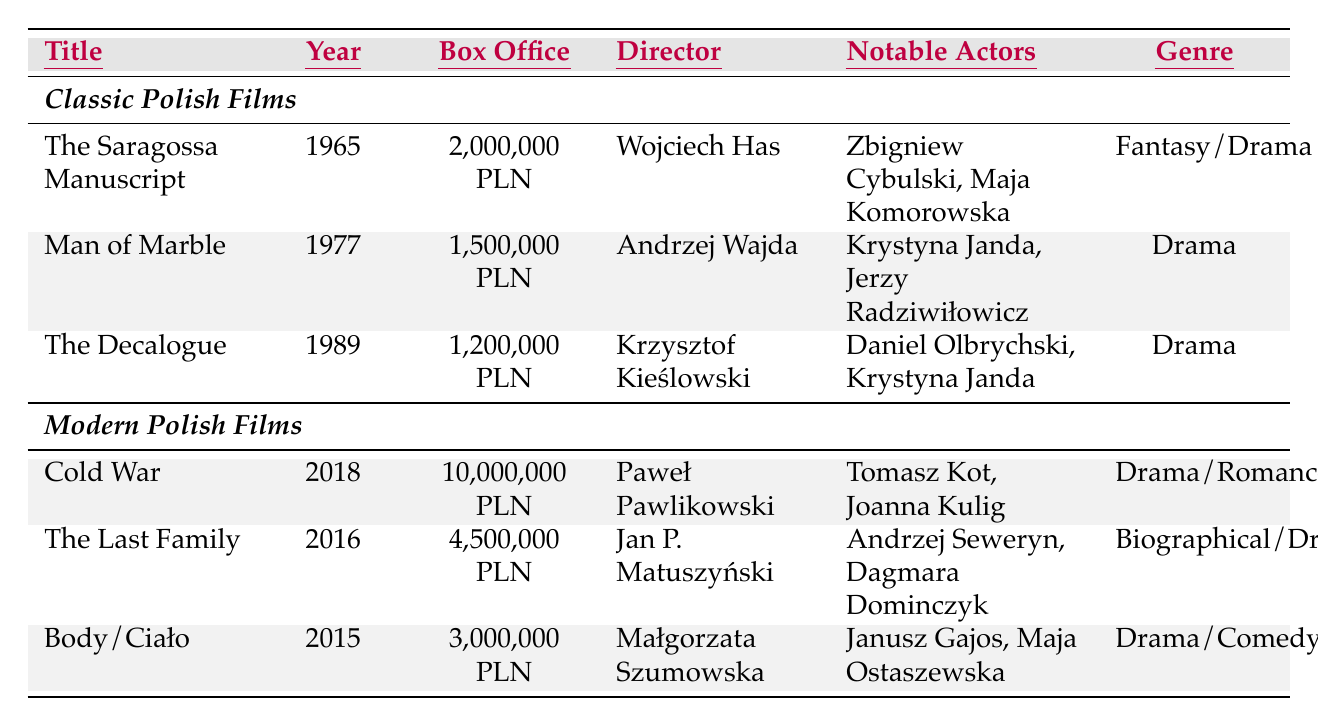What is the box office total of "The Saragossa Manuscript"? The box office figure for "The Saragossa Manuscript" is listed as 2,000,000 PLN in the table.
Answer: 2,000,000 PLN Who directed the film "Body/Ciało"? The director of "Body/Ciało" is Małgorzata Szumowska, as indicated in the table.
Answer: Małgorzata Szumowska Which film from the classic category has the highest box office revenue? "The Saragossa Manuscript" has the highest box office in the classic category, with 2,000,000 PLN, compared to the others.
Answer: "The Saragossa Manuscript" How many notable actors are featured in "Cold War"? "Cold War" features two notable actors: Tomasz Kot and Joanna Kulig, which can be seen in the corresponding row.
Answer: 2 What is the average box office for the classic Polish films listed? The sum of the box office of classic films is 2,000,000 + 1,500,000 + 1,200,000 = 4,700,000 PLN. There are three films, so the average is 4,700,000 / 3 = approximately 1,566,667 PLN.
Answer: 1,566,667 PLN Is "The Last Family" a classic Polish film? "The Last Family" is listed under modern Polish films, so it is not a classic film.
Answer: No What genre does "The Decalogue" belong to? The table lists "The Decalogue" as a Drama genre, which can be found in its corresponding row.
Answer: Drama How much more did "Cold War" earn at the box office than "Man of Marble"? "Cold War" earned 10,000,000 PLN while "Man of Marble" earned 1,500,000 PLN. The difference is 10,000,000 - 1,500,000 = 8,500,000 PLN.
Answer: 8,500,000 PLN What is the total box office revenue of both modern Polish films listed? The total box office for modern films is 10,000,000 + 4,500,000 + 3,000,000 = 17,500,000 PLN. This is obtained by summing the box office figures from all three modern films.
Answer: 17,500,000 PLN Which film has the latest release year among the classic Polish films? The latest release year among classic Polish films is 1989 for "The Decalogue". This can be determined by comparing the release years of all classic films listed.
Answer: 1989 